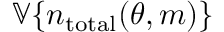Convert formula to latex. <formula><loc_0><loc_0><loc_500><loc_500>\mathbb { V } \{ n _ { t o t a l } ( \theta , m ) \}</formula> 